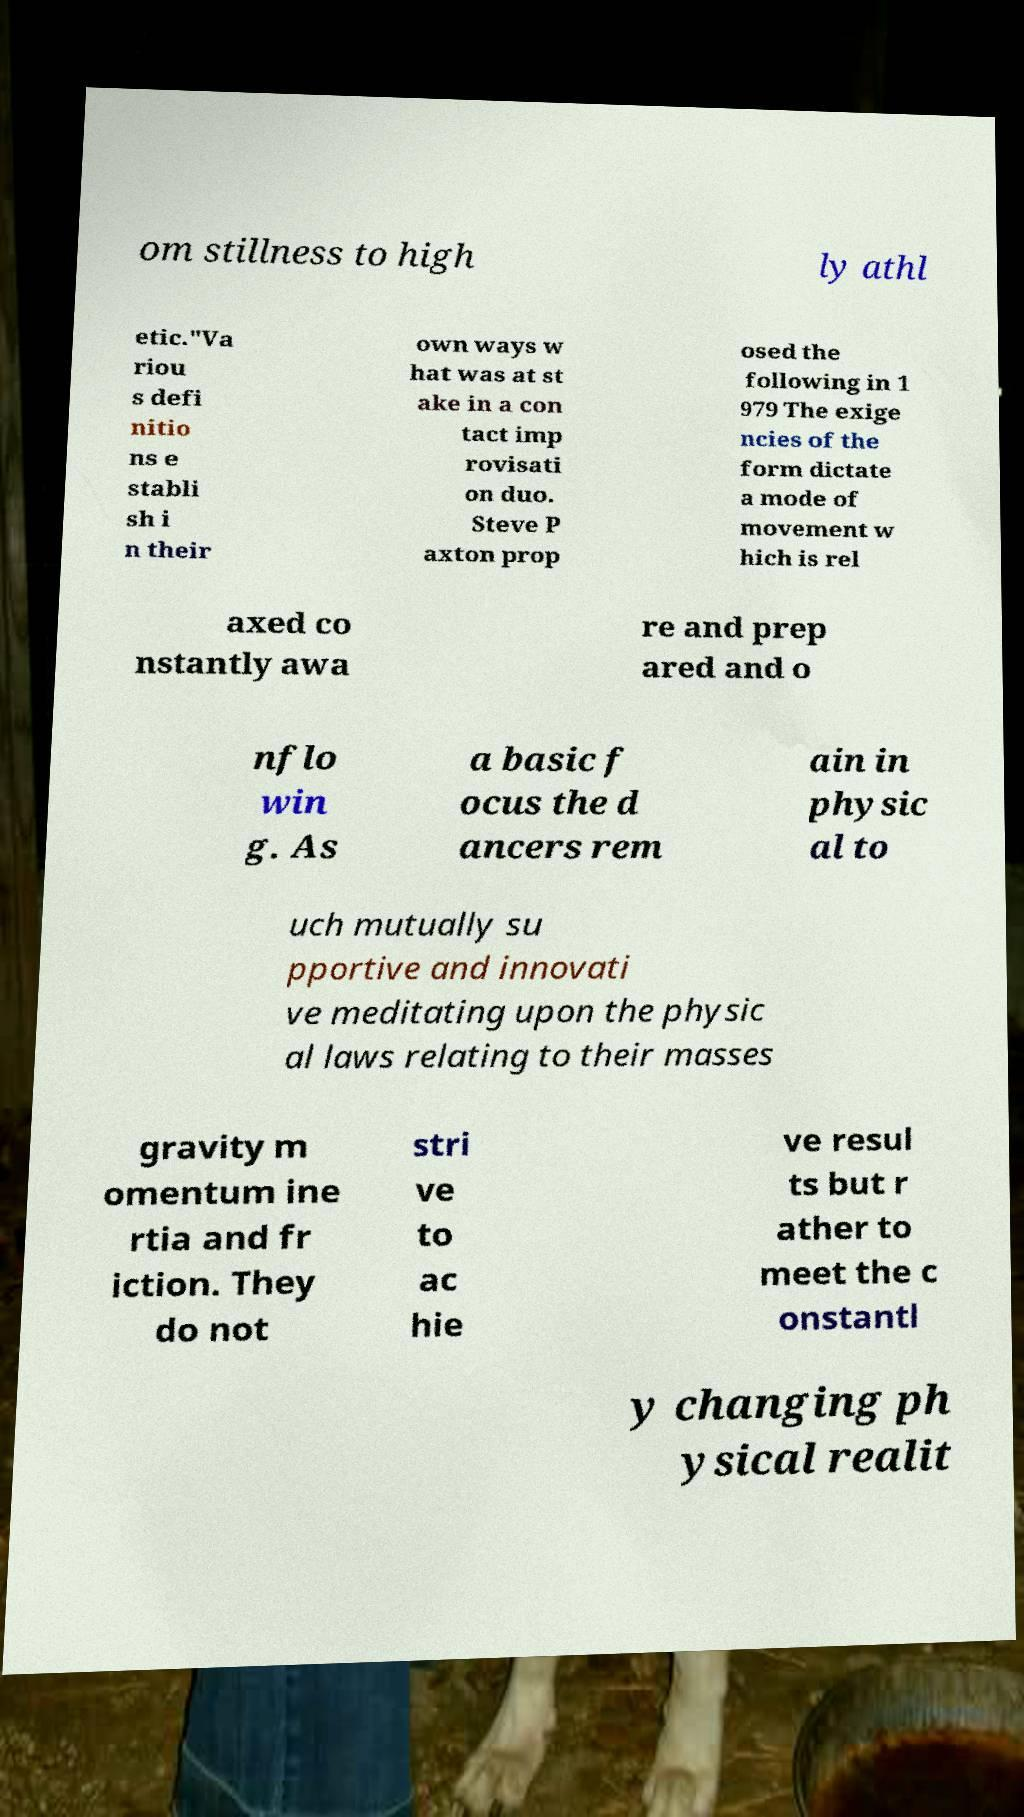Can you accurately transcribe the text from the provided image for me? om stillness to high ly athl etic."Va riou s defi nitio ns e stabli sh i n their own ways w hat was at st ake in a con tact imp rovisati on duo. Steve P axton prop osed the following in 1 979 The exige ncies of the form dictate a mode of movement w hich is rel axed co nstantly awa re and prep ared and o nflo win g. As a basic f ocus the d ancers rem ain in physic al to uch mutually su pportive and innovati ve meditating upon the physic al laws relating to their masses gravity m omentum ine rtia and fr iction. They do not stri ve to ac hie ve resul ts but r ather to meet the c onstantl y changing ph ysical realit 